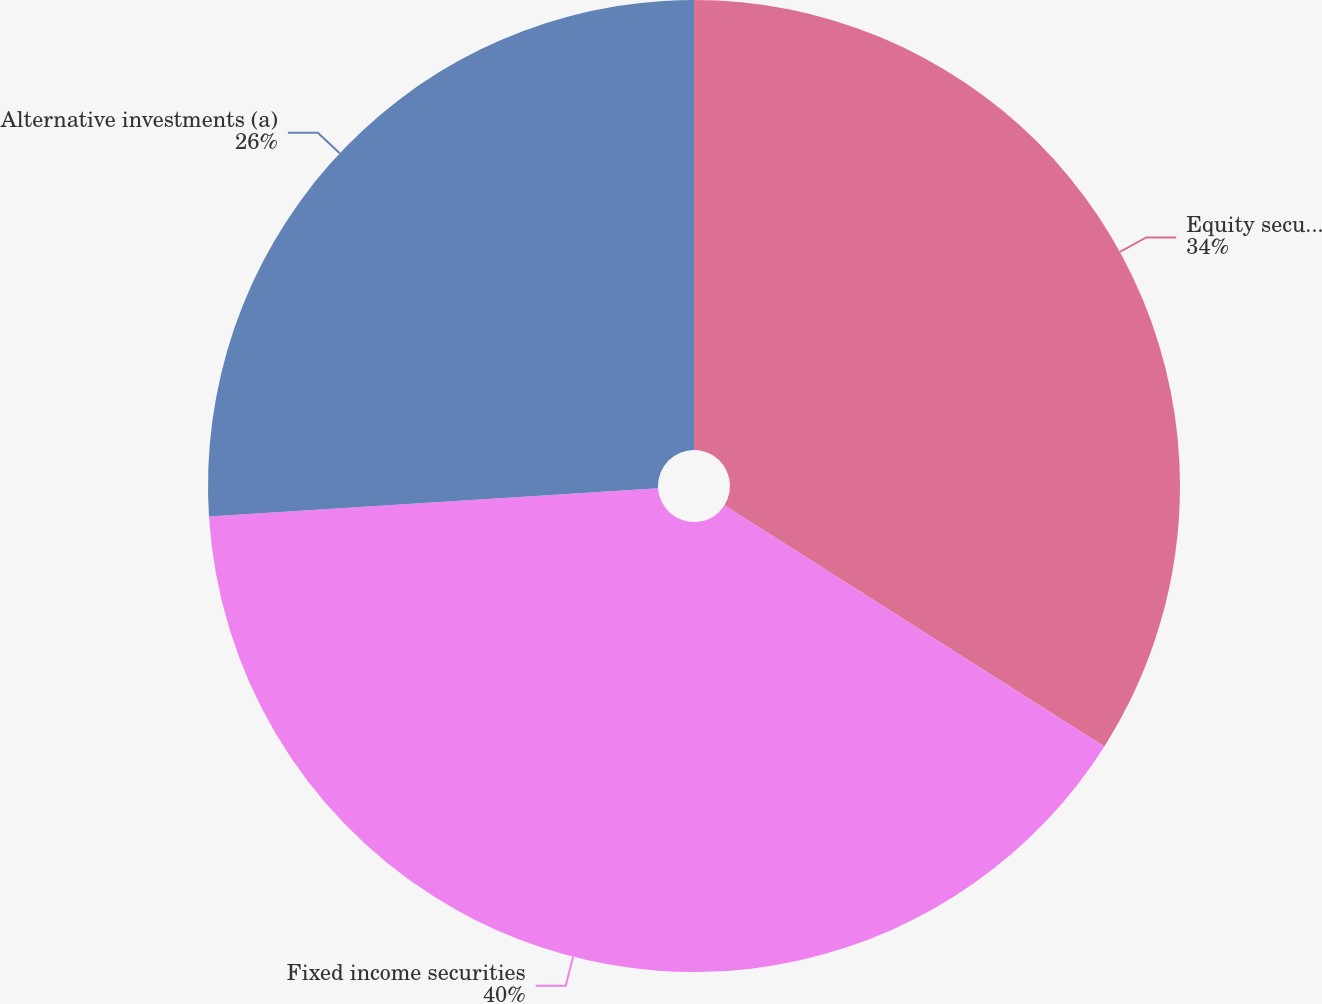Convert chart. <chart><loc_0><loc_0><loc_500><loc_500><pie_chart><fcel>Equity securities<fcel>Fixed income securities<fcel>Alternative investments (a)<nl><fcel>34.0%<fcel>40.0%<fcel>26.0%<nl></chart> 